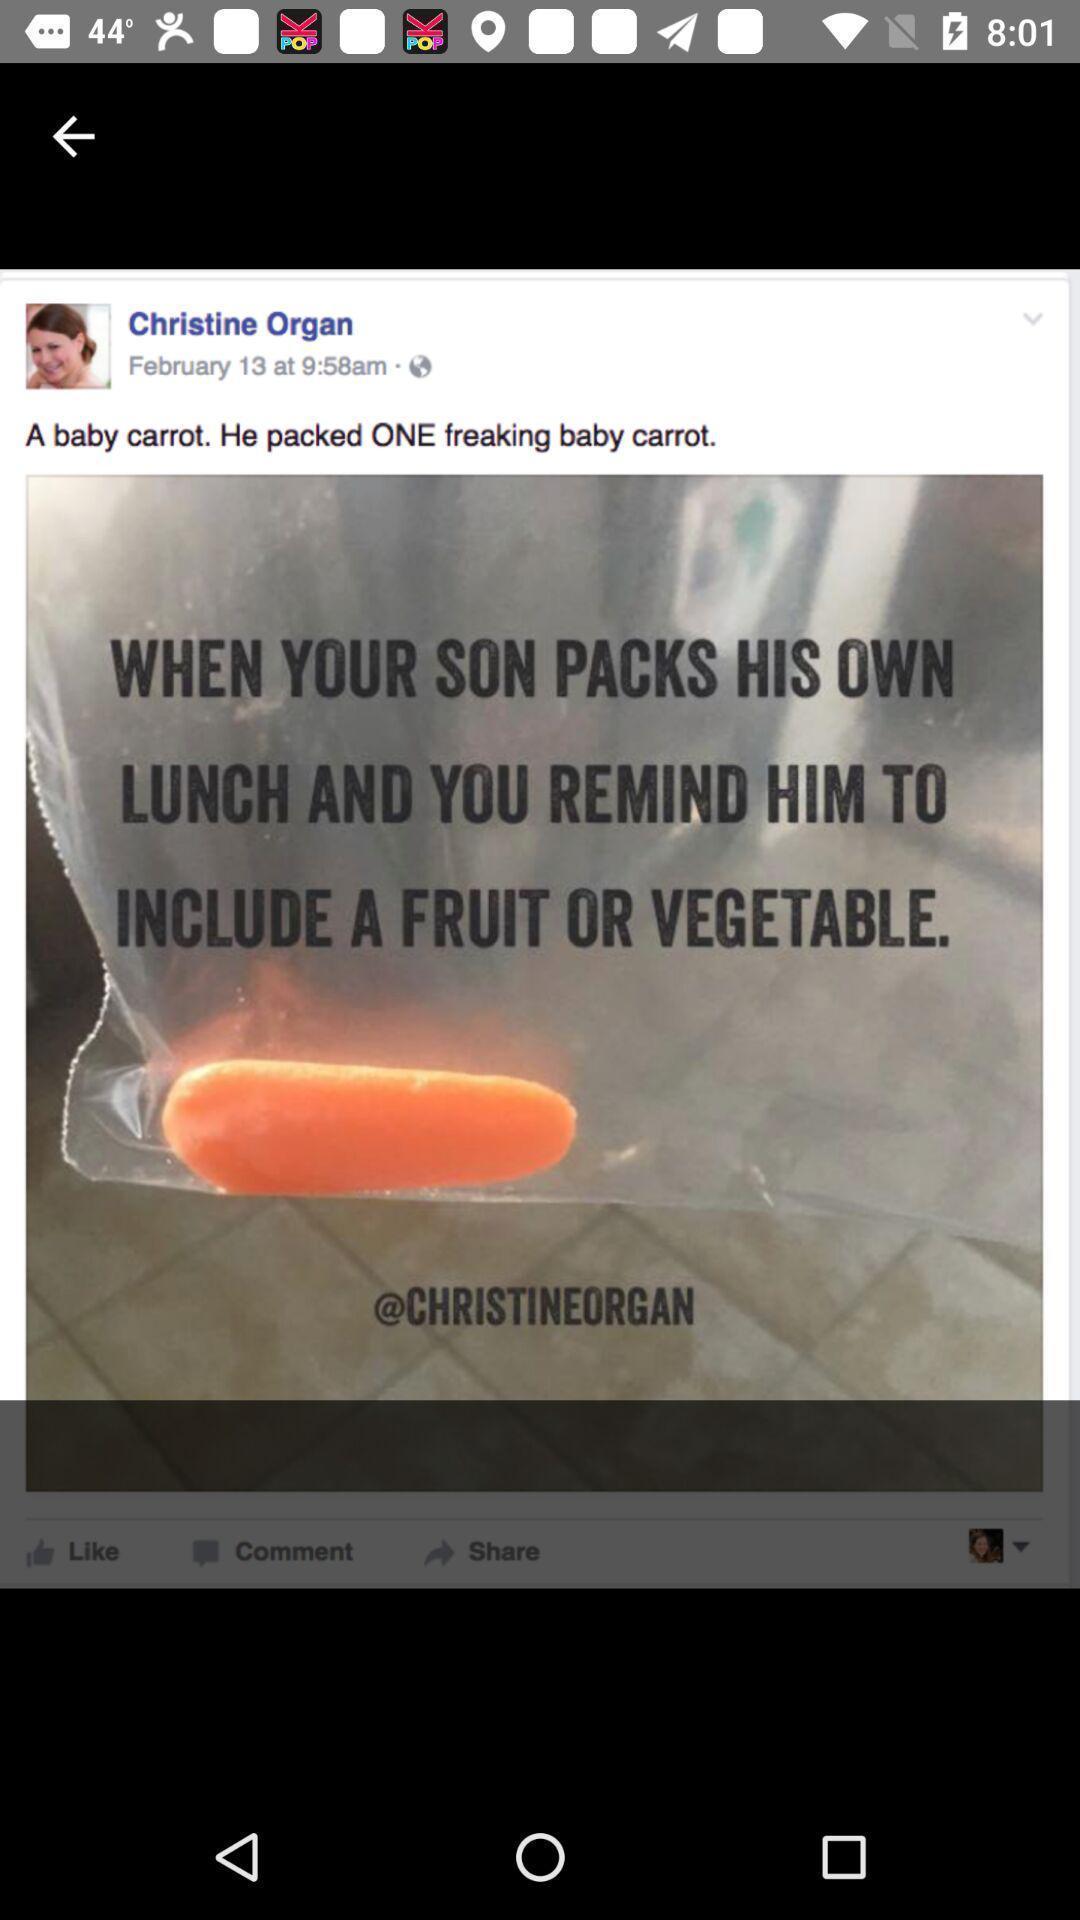Describe the content in this image. Screen showing the post i socail app. 